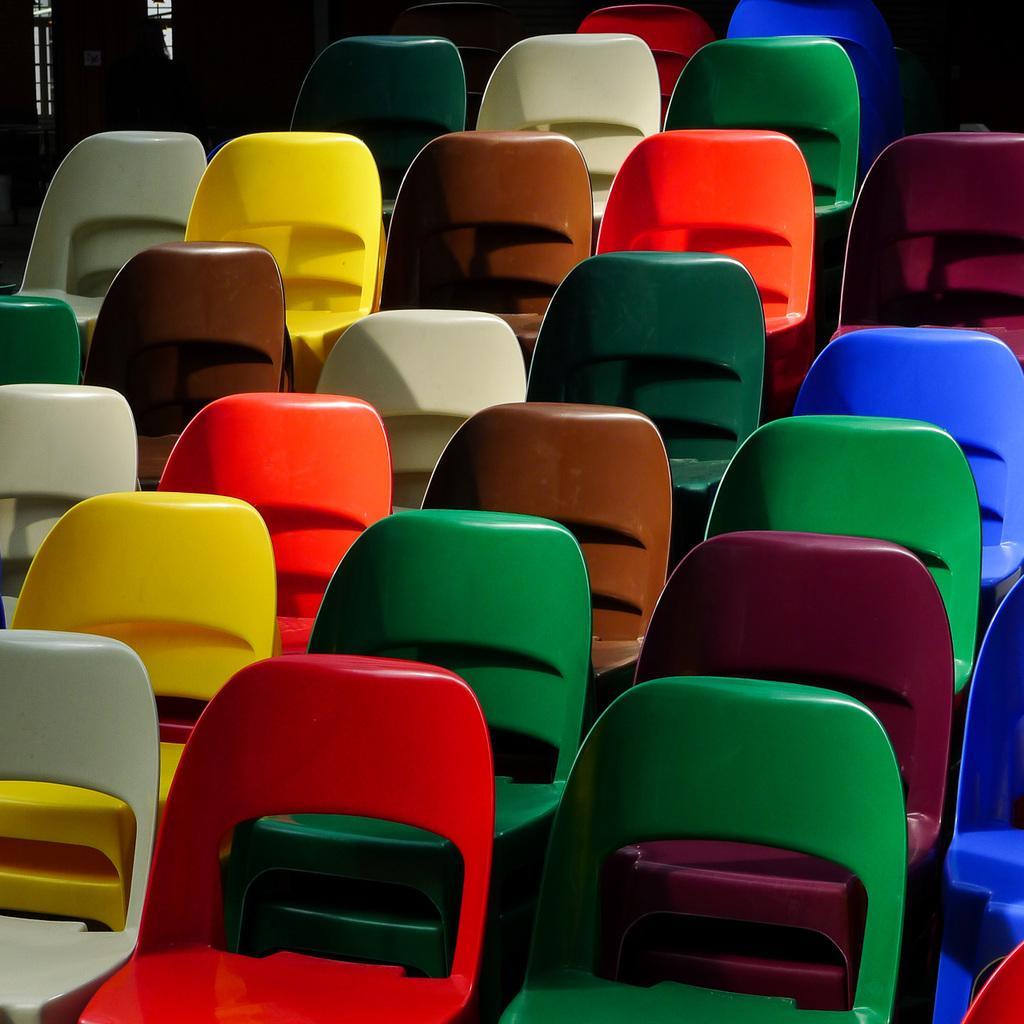Please provide a concise description of this image. In this image, we can see chairs. 